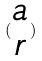<formula> <loc_0><loc_0><loc_500><loc_500>( \begin{matrix} a \\ r \end{matrix} )</formula> 